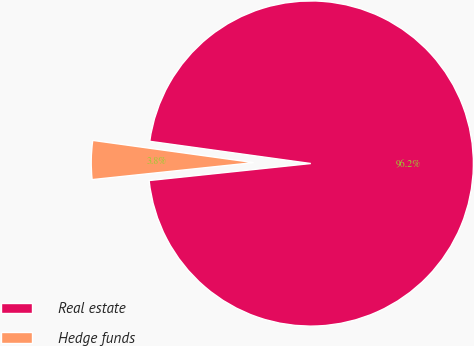Convert chart. <chart><loc_0><loc_0><loc_500><loc_500><pie_chart><fcel>Real estate<fcel>Hedge funds<nl><fcel>96.15%<fcel>3.85%<nl></chart> 